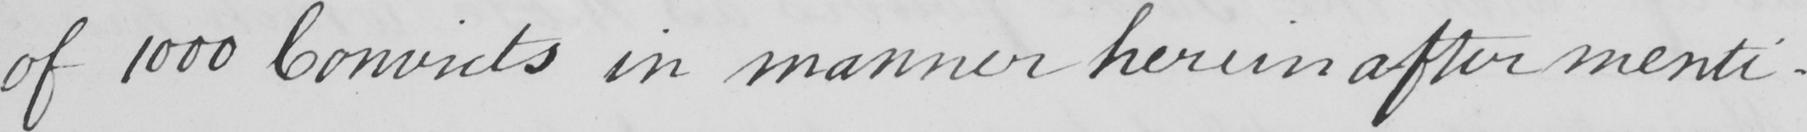What does this handwritten line say? of 1000 Convicts in manner herein after menti- 